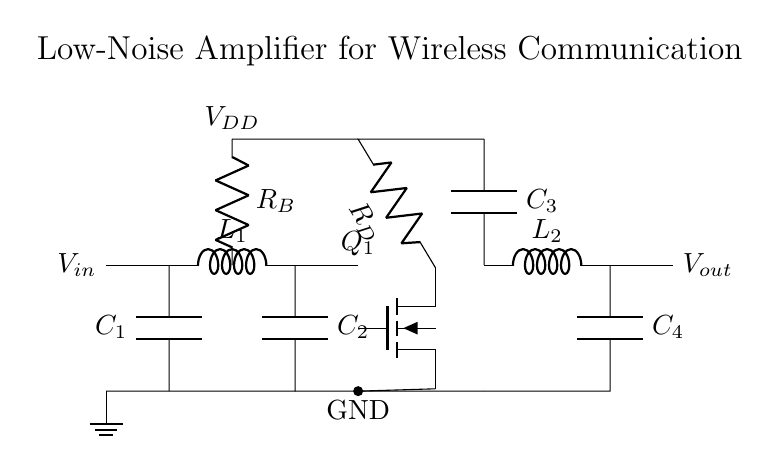What is the purpose of capacitor C1? Capacitor C1 is used for coupling, allowing AC signals to pass while blocking DC components, which helps isolate the input signal from the DC bias.
Answer: Coupling What type of transistor is used in this circuit? The circuit specifies a nfet, which stands for n-channel field-effect transistor. It is commonly used for its low noise and high gain characteristics in amplifiers.
Answer: nfet What does resistor R_D do in the circuit? Resistor R_D acts as a load for the transistor Q1, determining the gain of the amplifier by setting the output voltage characteristics and working with the transistor's output current.
Answer: Load How many matching network components are present in the circuit? The circuit has two matching network components: an inductor L1 and a capacitor C2, which optimize the input and output impedance to maximize power transfer.
Answer: Two What is the bias voltage applied to the transistor? The bias voltage is represented by V_DD in the diagram, which is crucial for setting the operating point of the transistor Q1 to ensure proper amplification of the input signal.
Answer: V_DD What is the role of capacitors C3 and C4 in the output section of the circuit? Capacitors C3 and C4 are used for output coupling and DC blocking, allowing the amplified AC signal to pass while preventing the DC component from reaching the next stage.
Answer: Coupling and blocking What is the effect of using a low-noise amplifier in wireless communication systems? A low-noise amplifier significantly enhances the signal-to-noise ratio (SNR) of weak signals received in wireless communication, improving overall system performance in terms of clarity and range.
Answer: Enhances SNR 